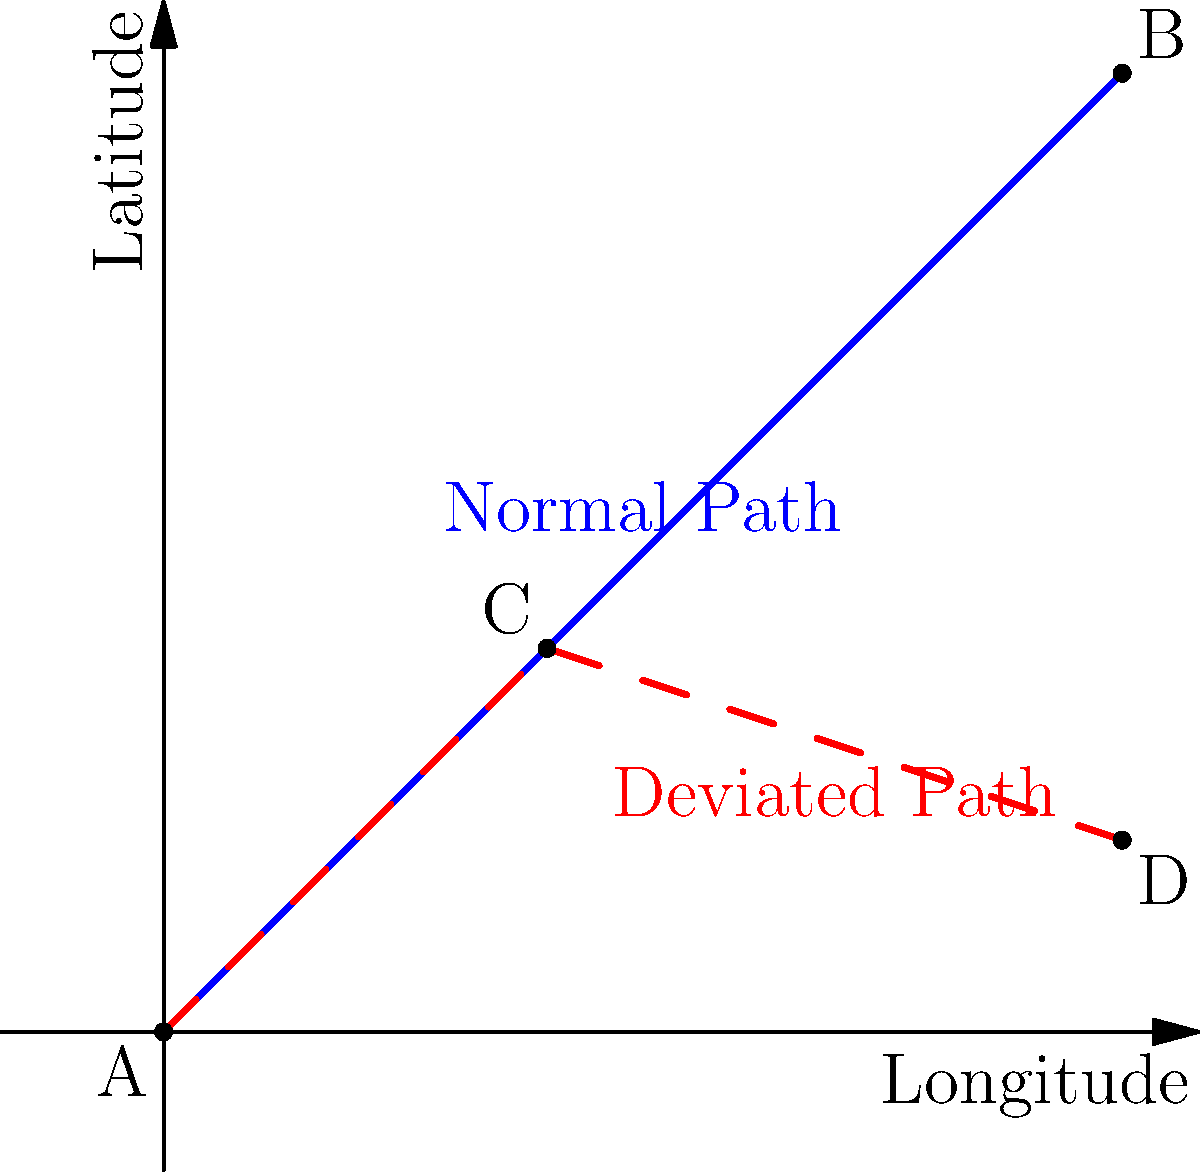Based on the radar data visualization above, which flight path shows an unusual deviation that might indicate a potential issue or change in course? To analyze the flight path patterns based on the radar data visualization:

1. Observe the two paths shown on the graph:
   - Blue solid line: represents the normal expected flight path
   - Red dashed line: represents a deviated flight path

2. Compare the two paths:
   - The blue path goes directly from point A to point B in a straight line
   - The red path starts at point A, reaches point C, then changes direction towards point D

3. Identify the deviation:
   - The red path initially follows a similar trajectory to the blue path
   - At point C, there's a significant change in direction
   - The final destination (point D) is different from the expected destination (point B)

4. Interpret the deviation:
   - A sudden change in direction and different final destination suggest an unusual deviation
   - This could indicate a potential issue or intentional change in course

5. Conclusion:
   The red dashed line shows an unusual deviation that might indicate a potential issue or change in course.
Answer: The red dashed path 